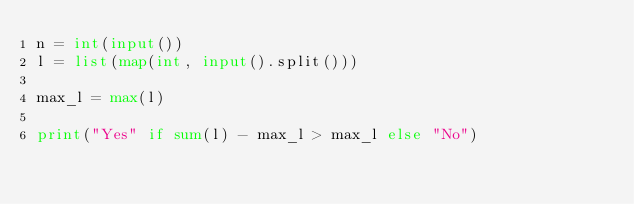Convert code to text. <code><loc_0><loc_0><loc_500><loc_500><_Python_>n = int(input())
l = list(map(int, input().split()))

max_l = max(l)

print("Yes" if sum(l) - max_l > max_l else "No")</code> 